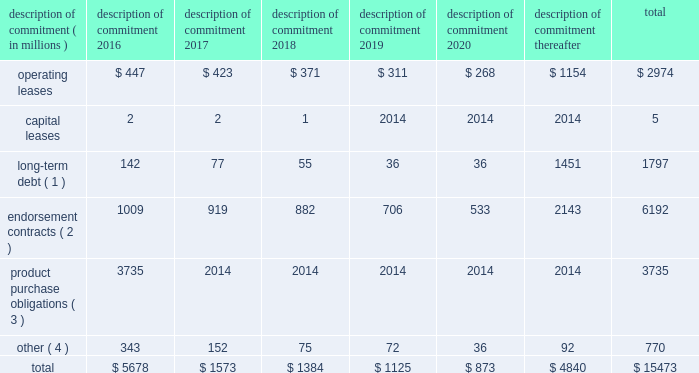Part ii were issued in an initial aggregate principal amount of $ 500 million at a 2.25% ( 2.25 % ) fixed , annual interest rate and will mature on may 1 , 2023 .
The 2043 senior notes were issued in an initial aggregate principal amount of $ 500 million at a 3.625% ( 3.625 % ) fixed , annual interest rate and will mature on may 1 , 2043 .
Interest on the senior notes is payable semi-annually on may 1 and november 1 of each year .
The issuance resulted in gross proceeds before expenses of $ 998 million .
On november 1 , 2011 , we entered into a committed credit facility agreement with a syndicate of banks which provides for up to $ 1 billion of borrowings with the option to increase borrowings to $ 1.5 billion with lender approval .
The facility matures november 1 , 2017 .
As of and for the periods ended may 31 , 2015 and 2014 , we had no amounts outstanding under our committed credit facility .
We currently have long-term debt ratings of aa- and a1 from standard and poor 2019s corporation and moody 2019s investor services , respectively .
If our long- term debt ratings were to decline , the facility fee and interest rate under our committed credit facility would increase .
Conversely , if our long-term debt rating were to improve , the facility fee and interest rate would decrease .
Changes in our long-term debt rating would not trigger acceleration of maturity of any then-outstanding borrowings or any future borrowings under the committed credit facility .
Under this committed revolving credit facility , we have agreed to various covenants .
These covenants include limits on our disposal of fixed assets , the amount of debt secured by liens we may incur , as well as a minimum capitalization ratio .
In the event we were to have any borrowings outstanding under this facility and failed to meet any covenant , and were unable to obtain a waiver from a majority of the banks in the syndicate , any borrowings would become immediately due and payable .
As of may 31 , 2015 , we were in full compliance with each of these covenants and believe it is unlikely we will fail to meet any of these covenants in the foreseeable future .
Liquidity is also provided by our $ 1 billion commercial paper program .
During the year ended may 31 , 2015 , we did not issue commercial paper , and as of may 31 , 2015 , there were no outstanding borrowings under this program .
We may issue commercial paper or other debt securities during fiscal 2016 depending on general corporate needs .
We currently have short-term debt ratings of a1+ and p1 from standard and poor 2019s corporation and moody 2019s investor services , respectively .
As of may 31 , 2015 , we had cash , cash equivalents and short-term investments totaling $ 5.9 billion , of which $ 4.2 billion was held by our foreign subsidiaries .
Included in cash and equivalents as of may 31 , 2015 was $ 968 million of cash collateral received from counterparties as a result of hedging activity .
Cash equivalents and short-term investments consist primarily of deposits held at major banks , money market funds , commercial paper , corporate notes , u.s .
Treasury obligations , u.s .
Government sponsored enterprise obligations and other investment grade fixed income securities .
Our fixed income investments are exposed to both credit and interest rate risk .
All of our investments are investment grade to minimize our credit risk .
While individual securities have varying durations , as of may 31 , 2015 the weighted average remaining duration of our short-term investments and cash equivalents portfolio was 79 days .
To date we have not experienced difficulty accessing the credit markets or incurred higher interest costs .
Future volatility in the capital markets , however , may increase costs associated with issuing commercial paper or other debt instruments or affect our ability to access those markets .
We believe that existing cash , cash equivalents , short-term investments and cash generated by operations , together with access to external sources of funds as described above , will be sufficient to meet our domestic and foreign capital needs in the foreseeable future .
We utilize a variety of tax planning and financing strategies to manage our worldwide cash and deploy funds to locations where they are needed .
We routinely repatriate a portion of our foreign earnings for which u.s .
Taxes have previously been provided .
We also indefinitely reinvest a significant portion of our foreign earnings , and our current plans do not demonstrate a need to repatriate these earnings .
Should we require additional capital in the united states , we may elect to repatriate indefinitely reinvested foreign funds or raise capital in the united states through debt .
If we were to repatriate indefinitely reinvested foreign funds , we would be required to accrue and pay additional u.s .
Taxes less applicable foreign tax credits .
If we elect to raise capital in the united states through debt , we would incur additional interest expense .
Off-balance sheet arrangements in connection with various contracts and agreements , we routinely provide indemnification relating to the enforceability of intellectual property rights , coverage for legal issues that arise and other items where we are acting as the guarantor .
Currently , we have several such agreements in place .
However , based on our historical experience and the estimated probability of future loss , we have determined that the fair value of such indemnification is not material to our financial position or results of operations .
Contractual obligations our significant long-term contractual obligations as of may 31 , 2015 and significant endorsement contracts , including related marketing commitments , entered into through the date of this report are as follows: .
( 1 ) the cash payments due for long-term debt include estimated interest payments .
Estimates of interest payments are based on outstanding principal amounts , applicable fixed interest rates or currently effective interest rates as of may 31 , 2015 ( if variable ) , timing of scheduled payments and the term of the debt obligations .
( 2 ) the amounts listed for endorsement contracts represent approximate amounts of base compensation and minimum guaranteed royalty fees we are obligated to pay athlete , sport team and league endorsers of our products .
Actual payments under some contracts may be higher than the amounts listed as these contracts provide for bonuses to be paid to the endorsers based upon athletic achievements and/or royalties on product sales in future periods .
Actual payments under some contracts may also be lower as these contracts include provisions for reduced payments if athletic performance declines in future periods .
In addition to the cash payments , we are obligated to furnish our endorsers with nike product for their use .
It is not possible to determine how much we will spend on this product on an annual basis as the contracts generally do not stipulate a specific amount of cash to be spent on the product .
The amount of product provided to the endorsers will depend on many factors , including general playing conditions , the number of sporting events in which they participate and our own decisions regarding product and marketing initiatives .
In addition , the costs to design , develop , source and purchase the products furnished to the endorsers are incurred over a period of time and are not necessarily tracked separately from similar costs incurred for products sold to customers. .
What percentage of endorsement contracts is currently due after 2020? 
Computations: (2143 / 6192)
Answer: 0.34609. 